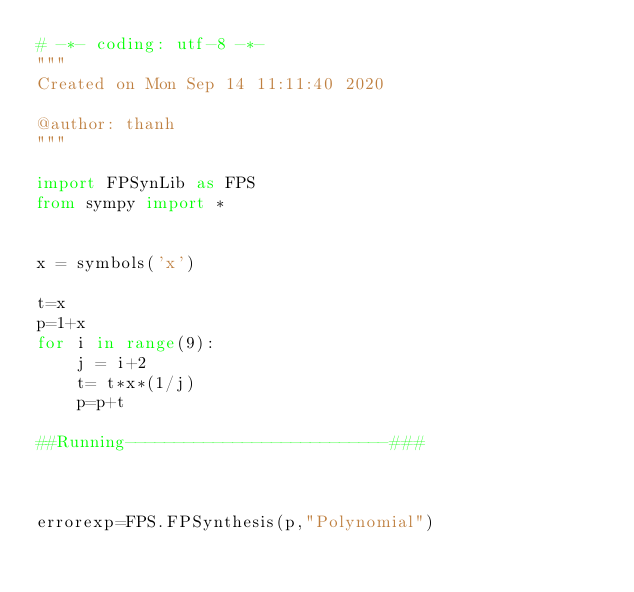Convert code to text. <code><loc_0><loc_0><loc_500><loc_500><_Python_># -*- coding: utf-8 -*-
"""
Created on Mon Sep 14 11:11:40 2020

@author: thanh
"""

import FPSynLib as FPS
from sympy import *


x = symbols('x')

t=x
p=1+x
for i in range(9):
    j = i+2
    t= t*x*(1/j)
    p=p+t

##Running---------------------------###



errorexp=FPS.FPSynthesis(p,"Polynomial")

</code> 